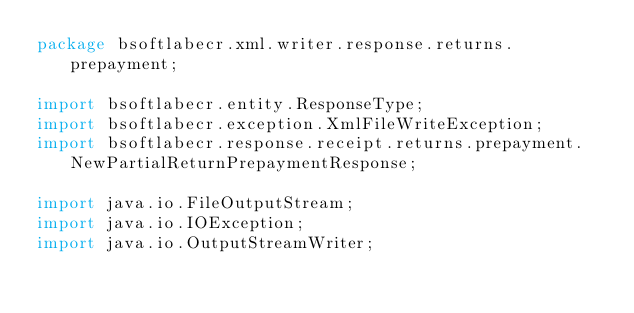Convert code to text. <code><loc_0><loc_0><loc_500><loc_500><_Java_>package bsoftlabecr.xml.writer.response.returns.prepayment;

import bsoftlabecr.entity.ResponseType;
import bsoftlabecr.exception.XmlFileWriteException;
import bsoftlabecr.response.receipt.returns.prepayment.NewPartialReturnPrepaymentResponse;

import java.io.FileOutputStream;
import java.io.IOException;
import java.io.OutputStreamWriter;</code> 